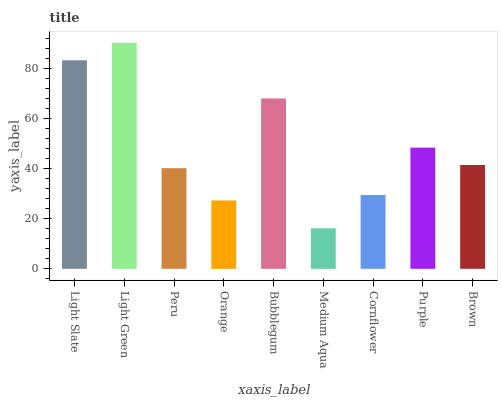Is Peru the minimum?
Answer yes or no. No. Is Peru the maximum?
Answer yes or no. No. Is Light Green greater than Peru?
Answer yes or no. Yes. Is Peru less than Light Green?
Answer yes or no. Yes. Is Peru greater than Light Green?
Answer yes or no. No. Is Light Green less than Peru?
Answer yes or no. No. Is Brown the high median?
Answer yes or no. Yes. Is Brown the low median?
Answer yes or no. Yes. Is Orange the high median?
Answer yes or no. No. Is Peru the low median?
Answer yes or no. No. 